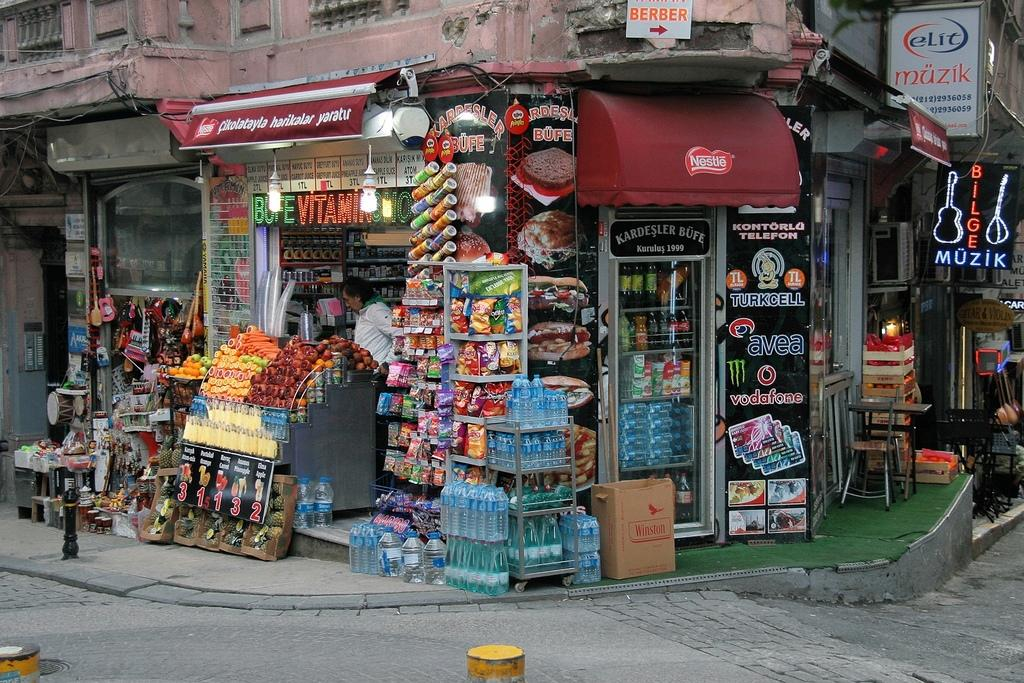<image>
Describe the image concisely. The store front has signs for Nestle, Pringles, and Vodafone. 